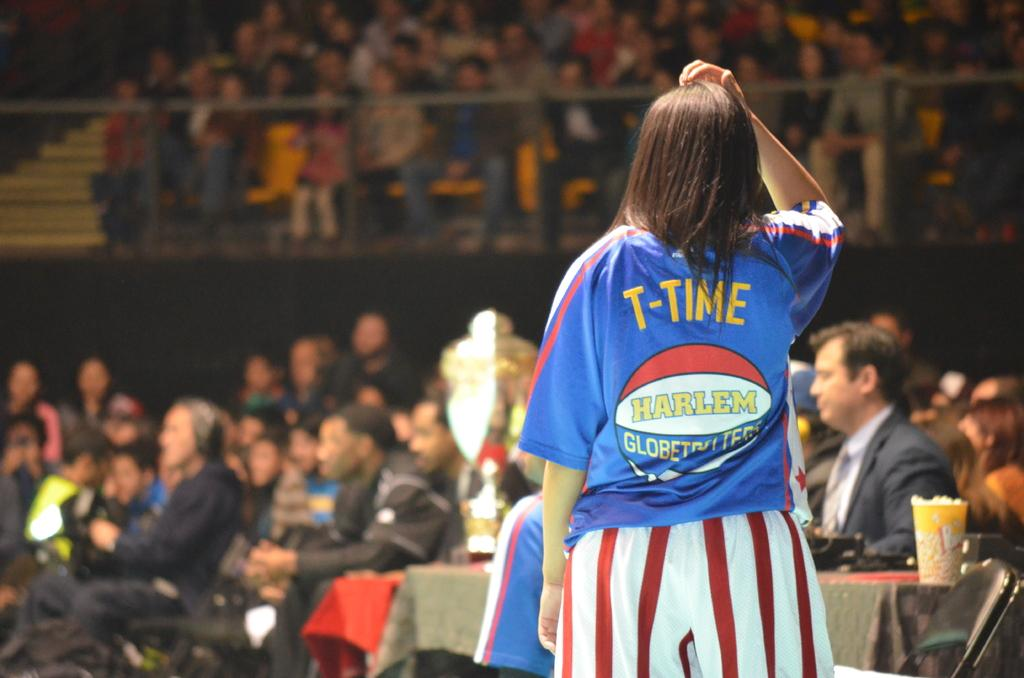<image>
Present a compact description of the photo's key features. A women standing with the name T-Time on her back. 